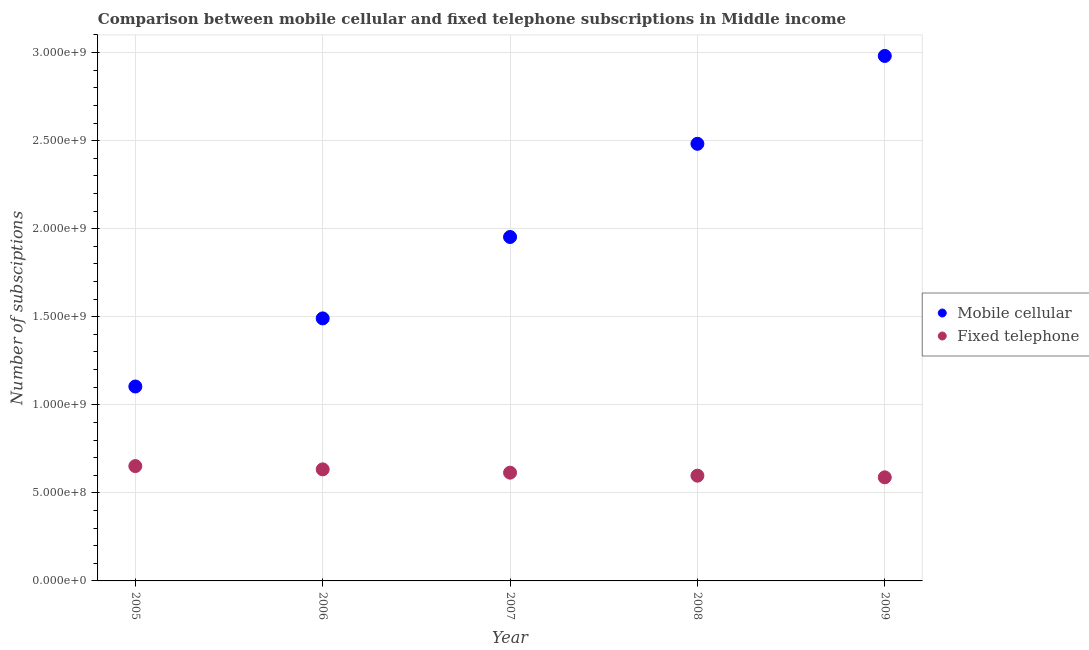How many different coloured dotlines are there?
Your answer should be compact. 2. Is the number of dotlines equal to the number of legend labels?
Your answer should be very brief. Yes. What is the number of mobile cellular subscriptions in 2005?
Provide a succinct answer. 1.10e+09. Across all years, what is the maximum number of mobile cellular subscriptions?
Offer a terse response. 2.98e+09. Across all years, what is the minimum number of fixed telephone subscriptions?
Provide a short and direct response. 5.88e+08. In which year was the number of mobile cellular subscriptions maximum?
Provide a short and direct response. 2009. In which year was the number of fixed telephone subscriptions minimum?
Provide a succinct answer. 2009. What is the total number of mobile cellular subscriptions in the graph?
Provide a short and direct response. 1.00e+1. What is the difference between the number of fixed telephone subscriptions in 2005 and that in 2009?
Your answer should be compact. 6.38e+07. What is the difference between the number of fixed telephone subscriptions in 2009 and the number of mobile cellular subscriptions in 2005?
Provide a short and direct response. -5.16e+08. What is the average number of fixed telephone subscriptions per year?
Make the answer very short. 6.17e+08. In the year 2005, what is the difference between the number of mobile cellular subscriptions and number of fixed telephone subscriptions?
Your answer should be compact. 4.52e+08. In how many years, is the number of mobile cellular subscriptions greater than 800000000?
Your response must be concise. 5. What is the ratio of the number of fixed telephone subscriptions in 2007 to that in 2009?
Your answer should be very brief. 1.04. What is the difference between the highest and the second highest number of mobile cellular subscriptions?
Your answer should be very brief. 4.99e+08. What is the difference between the highest and the lowest number of fixed telephone subscriptions?
Make the answer very short. 6.38e+07. Does the number of fixed telephone subscriptions monotonically increase over the years?
Ensure brevity in your answer.  No. Is the number of fixed telephone subscriptions strictly greater than the number of mobile cellular subscriptions over the years?
Make the answer very short. No. How many years are there in the graph?
Ensure brevity in your answer.  5. What is the difference between two consecutive major ticks on the Y-axis?
Provide a succinct answer. 5.00e+08. Does the graph contain grids?
Ensure brevity in your answer.  Yes. How many legend labels are there?
Provide a short and direct response. 2. How are the legend labels stacked?
Offer a terse response. Vertical. What is the title of the graph?
Offer a very short reply. Comparison between mobile cellular and fixed telephone subscriptions in Middle income. Does "US$" appear as one of the legend labels in the graph?
Ensure brevity in your answer.  No. What is the label or title of the Y-axis?
Provide a succinct answer. Number of subsciptions. What is the Number of subsciptions of Mobile cellular in 2005?
Your answer should be very brief. 1.10e+09. What is the Number of subsciptions in Fixed telephone in 2005?
Ensure brevity in your answer.  6.52e+08. What is the Number of subsciptions in Mobile cellular in 2006?
Your answer should be compact. 1.49e+09. What is the Number of subsciptions in Fixed telephone in 2006?
Give a very brief answer. 6.33e+08. What is the Number of subsciptions in Mobile cellular in 2007?
Make the answer very short. 1.95e+09. What is the Number of subsciptions in Fixed telephone in 2007?
Your answer should be compact. 6.15e+08. What is the Number of subsciptions in Mobile cellular in 2008?
Your answer should be very brief. 2.48e+09. What is the Number of subsciptions of Fixed telephone in 2008?
Provide a short and direct response. 5.98e+08. What is the Number of subsciptions of Mobile cellular in 2009?
Give a very brief answer. 2.98e+09. What is the Number of subsciptions in Fixed telephone in 2009?
Provide a succinct answer. 5.88e+08. Across all years, what is the maximum Number of subsciptions in Mobile cellular?
Offer a very short reply. 2.98e+09. Across all years, what is the maximum Number of subsciptions in Fixed telephone?
Provide a succinct answer. 6.52e+08. Across all years, what is the minimum Number of subsciptions in Mobile cellular?
Provide a short and direct response. 1.10e+09. Across all years, what is the minimum Number of subsciptions of Fixed telephone?
Offer a terse response. 5.88e+08. What is the total Number of subsciptions of Mobile cellular in the graph?
Your answer should be very brief. 1.00e+1. What is the total Number of subsciptions in Fixed telephone in the graph?
Give a very brief answer. 3.09e+09. What is the difference between the Number of subsciptions of Mobile cellular in 2005 and that in 2006?
Keep it short and to the point. -3.87e+08. What is the difference between the Number of subsciptions of Fixed telephone in 2005 and that in 2006?
Your response must be concise. 1.87e+07. What is the difference between the Number of subsciptions of Mobile cellular in 2005 and that in 2007?
Provide a short and direct response. -8.49e+08. What is the difference between the Number of subsciptions in Fixed telephone in 2005 and that in 2007?
Ensure brevity in your answer.  3.74e+07. What is the difference between the Number of subsciptions of Mobile cellular in 2005 and that in 2008?
Keep it short and to the point. -1.38e+09. What is the difference between the Number of subsciptions of Fixed telephone in 2005 and that in 2008?
Ensure brevity in your answer.  5.44e+07. What is the difference between the Number of subsciptions in Mobile cellular in 2005 and that in 2009?
Offer a very short reply. -1.88e+09. What is the difference between the Number of subsciptions of Fixed telephone in 2005 and that in 2009?
Give a very brief answer. 6.38e+07. What is the difference between the Number of subsciptions in Mobile cellular in 2006 and that in 2007?
Keep it short and to the point. -4.62e+08. What is the difference between the Number of subsciptions of Fixed telephone in 2006 and that in 2007?
Your answer should be very brief. 1.87e+07. What is the difference between the Number of subsciptions of Mobile cellular in 2006 and that in 2008?
Offer a terse response. -9.91e+08. What is the difference between the Number of subsciptions in Fixed telephone in 2006 and that in 2008?
Ensure brevity in your answer.  3.57e+07. What is the difference between the Number of subsciptions of Mobile cellular in 2006 and that in 2009?
Your answer should be compact. -1.49e+09. What is the difference between the Number of subsciptions of Fixed telephone in 2006 and that in 2009?
Offer a terse response. 4.52e+07. What is the difference between the Number of subsciptions of Mobile cellular in 2007 and that in 2008?
Make the answer very short. -5.29e+08. What is the difference between the Number of subsciptions in Fixed telephone in 2007 and that in 2008?
Your response must be concise. 1.70e+07. What is the difference between the Number of subsciptions of Mobile cellular in 2007 and that in 2009?
Make the answer very short. -1.03e+09. What is the difference between the Number of subsciptions of Fixed telephone in 2007 and that in 2009?
Your response must be concise. 2.65e+07. What is the difference between the Number of subsciptions of Mobile cellular in 2008 and that in 2009?
Offer a very short reply. -4.99e+08. What is the difference between the Number of subsciptions of Fixed telephone in 2008 and that in 2009?
Offer a terse response. 9.43e+06. What is the difference between the Number of subsciptions in Mobile cellular in 2005 and the Number of subsciptions in Fixed telephone in 2006?
Ensure brevity in your answer.  4.71e+08. What is the difference between the Number of subsciptions in Mobile cellular in 2005 and the Number of subsciptions in Fixed telephone in 2007?
Give a very brief answer. 4.89e+08. What is the difference between the Number of subsciptions in Mobile cellular in 2005 and the Number of subsciptions in Fixed telephone in 2008?
Offer a very short reply. 5.06e+08. What is the difference between the Number of subsciptions of Mobile cellular in 2005 and the Number of subsciptions of Fixed telephone in 2009?
Your response must be concise. 5.16e+08. What is the difference between the Number of subsciptions in Mobile cellular in 2006 and the Number of subsciptions in Fixed telephone in 2007?
Make the answer very short. 8.76e+08. What is the difference between the Number of subsciptions in Mobile cellular in 2006 and the Number of subsciptions in Fixed telephone in 2008?
Offer a very short reply. 8.93e+08. What is the difference between the Number of subsciptions in Mobile cellular in 2006 and the Number of subsciptions in Fixed telephone in 2009?
Your response must be concise. 9.02e+08. What is the difference between the Number of subsciptions of Mobile cellular in 2007 and the Number of subsciptions of Fixed telephone in 2008?
Your answer should be compact. 1.36e+09. What is the difference between the Number of subsciptions in Mobile cellular in 2007 and the Number of subsciptions in Fixed telephone in 2009?
Provide a short and direct response. 1.36e+09. What is the difference between the Number of subsciptions of Mobile cellular in 2008 and the Number of subsciptions of Fixed telephone in 2009?
Your response must be concise. 1.89e+09. What is the average Number of subsciptions in Mobile cellular per year?
Keep it short and to the point. 2.00e+09. What is the average Number of subsciptions in Fixed telephone per year?
Provide a short and direct response. 6.17e+08. In the year 2005, what is the difference between the Number of subsciptions in Mobile cellular and Number of subsciptions in Fixed telephone?
Offer a very short reply. 4.52e+08. In the year 2006, what is the difference between the Number of subsciptions of Mobile cellular and Number of subsciptions of Fixed telephone?
Provide a short and direct response. 8.57e+08. In the year 2007, what is the difference between the Number of subsciptions of Mobile cellular and Number of subsciptions of Fixed telephone?
Provide a short and direct response. 1.34e+09. In the year 2008, what is the difference between the Number of subsciptions of Mobile cellular and Number of subsciptions of Fixed telephone?
Ensure brevity in your answer.  1.88e+09. In the year 2009, what is the difference between the Number of subsciptions of Mobile cellular and Number of subsciptions of Fixed telephone?
Make the answer very short. 2.39e+09. What is the ratio of the Number of subsciptions of Mobile cellular in 2005 to that in 2006?
Your answer should be compact. 0.74. What is the ratio of the Number of subsciptions in Fixed telephone in 2005 to that in 2006?
Provide a short and direct response. 1.03. What is the ratio of the Number of subsciptions in Mobile cellular in 2005 to that in 2007?
Offer a very short reply. 0.57. What is the ratio of the Number of subsciptions in Fixed telephone in 2005 to that in 2007?
Provide a succinct answer. 1.06. What is the ratio of the Number of subsciptions in Mobile cellular in 2005 to that in 2008?
Your answer should be compact. 0.44. What is the ratio of the Number of subsciptions in Fixed telephone in 2005 to that in 2008?
Keep it short and to the point. 1.09. What is the ratio of the Number of subsciptions in Mobile cellular in 2005 to that in 2009?
Offer a very short reply. 0.37. What is the ratio of the Number of subsciptions of Fixed telephone in 2005 to that in 2009?
Your response must be concise. 1.11. What is the ratio of the Number of subsciptions of Mobile cellular in 2006 to that in 2007?
Your answer should be very brief. 0.76. What is the ratio of the Number of subsciptions in Fixed telephone in 2006 to that in 2007?
Your answer should be very brief. 1.03. What is the ratio of the Number of subsciptions of Mobile cellular in 2006 to that in 2008?
Your response must be concise. 0.6. What is the ratio of the Number of subsciptions of Fixed telephone in 2006 to that in 2008?
Give a very brief answer. 1.06. What is the ratio of the Number of subsciptions of Mobile cellular in 2006 to that in 2009?
Your answer should be very brief. 0.5. What is the ratio of the Number of subsciptions of Fixed telephone in 2006 to that in 2009?
Your answer should be compact. 1.08. What is the ratio of the Number of subsciptions of Mobile cellular in 2007 to that in 2008?
Keep it short and to the point. 0.79. What is the ratio of the Number of subsciptions in Fixed telephone in 2007 to that in 2008?
Offer a terse response. 1.03. What is the ratio of the Number of subsciptions of Mobile cellular in 2007 to that in 2009?
Give a very brief answer. 0.66. What is the ratio of the Number of subsciptions in Fixed telephone in 2007 to that in 2009?
Your answer should be very brief. 1.04. What is the ratio of the Number of subsciptions in Mobile cellular in 2008 to that in 2009?
Offer a very short reply. 0.83. What is the ratio of the Number of subsciptions in Fixed telephone in 2008 to that in 2009?
Your answer should be very brief. 1.02. What is the difference between the highest and the second highest Number of subsciptions in Mobile cellular?
Ensure brevity in your answer.  4.99e+08. What is the difference between the highest and the second highest Number of subsciptions of Fixed telephone?
Your response must be concise. 1.87e+07. What is the difference between the highest and the lowest Number of subsciptions in Mobile cellular?
Provide a succinct answer. 1.88e+09. What is the difference between the highest and the lowest Number of subsciptions in Fixed telephone?
Your response must be concise. 6.38e+07. 